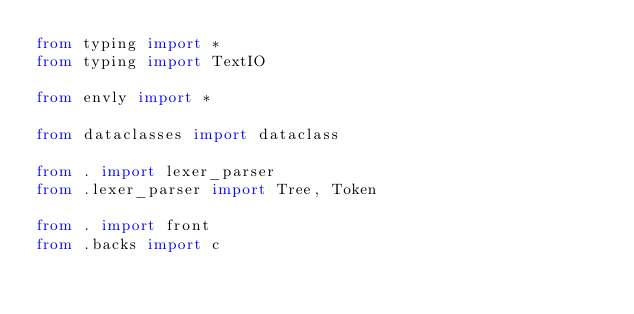Convert code to text. <code><loc_0><loc_0><loc_500><loc_500><_Python_>from typing import *
from typing import TextIO

from envly import *

from dataclasses import dataclass

from . import lexer_parser
from .lexer_parser import Tree, Token

from . import front
from .backs import c

</code> 